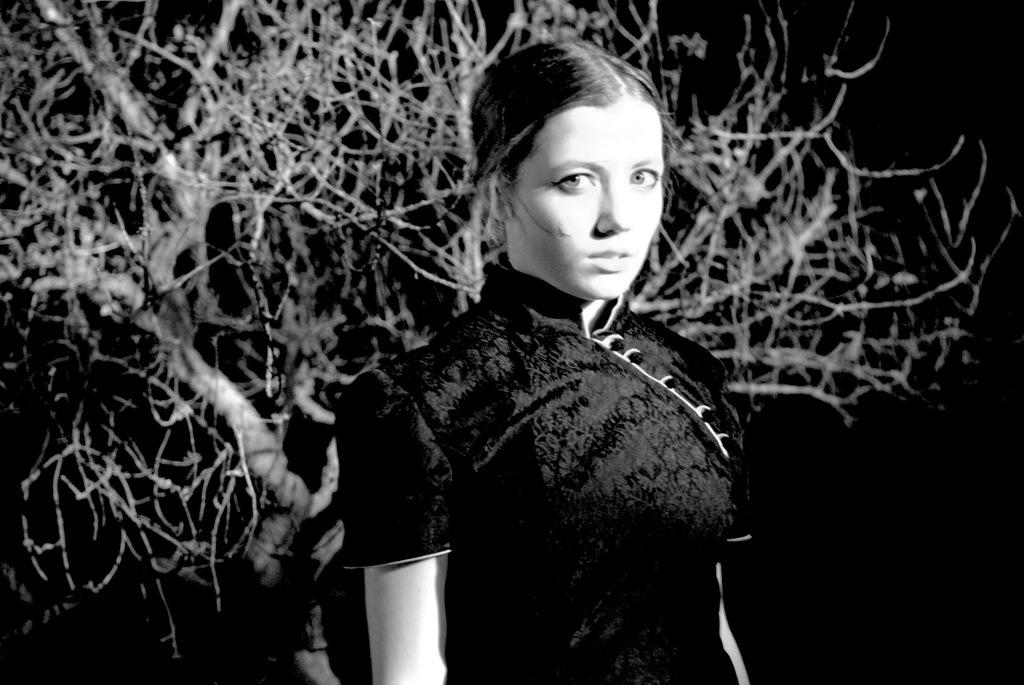What is the color scheme of the image? The image is black and white. Who is present in the image? There is a woman in the image. What natural element can be seen in the image? There is a tree in the image. How would you describe the overall lighting in the image? The background of the image is dark. How many ducks are learning to swim in the image? There are no ducks present in the image, and therefore no learning or swimming activity can be observed. 